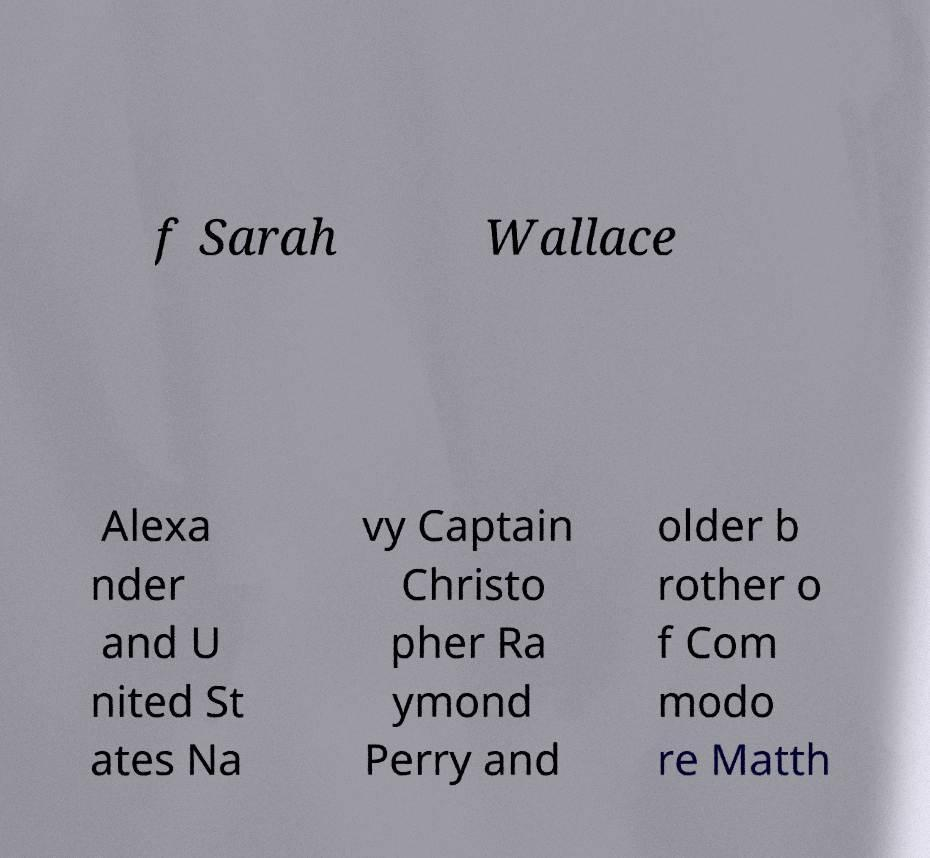Can you accurately transcribe the text from the provided image for me? f Sarah Wallace Alexa nder and U nited St ates Na vy Captain Christo pher Ra ymond Perry and older b rother o f Com modo re Matth 